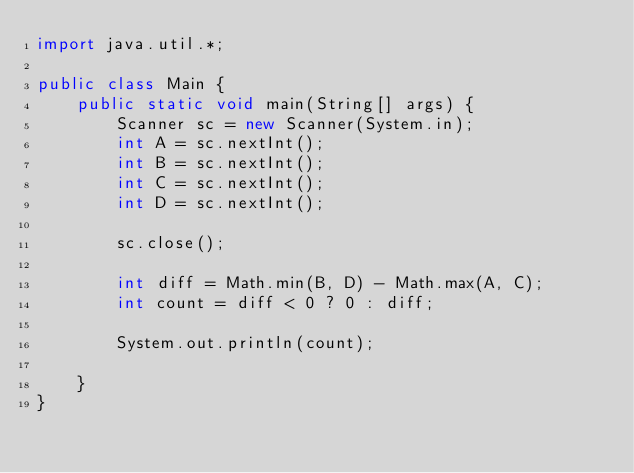<code> <loc_0><loc_0><loc_500><loc_500><_Java_>import java.util.*;

public class Main {
    public static void main(String[] args) {
        Scanner sc = new Scanner(System.in);
        int A = sc.nextInt();
        int B = sc.nextInt();
        int C = sc.nextInt();
        int D = sc.nextInt();

        sc.close();

        int diff = Math.min(B, D) - Math.max(A, C);
        int count = diff < 0 ? 0 : diff;

        System.out.println(count);

    }
}</code> 